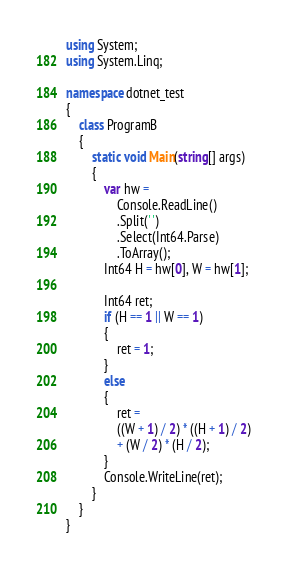Convert code to text. <code><loc_0><loc_0><loc_500><loc_500><_C#_>using System;
using System.Linq;

namespace dotnet_test
{
    class ProgramB
    {
        static void Main(string[] args)
        {
            var hw =
                Console.ReadLine()
                .Split(' ')
                .Select(Int64.Parse)
                .ToArray();
            Int64 H = hw[0], W = hw[1];

            Int64 ret;
            if (H == 1 || W == 1)
            {
                ret = 1;
            }
            else
            {
                ret =
                ((W + 1) / 2) * ((H + 1) / 2)
                + (W / 2) * (H / 2);
            }
            Console.WriteLine(ret);
        }
    }
}</code> 